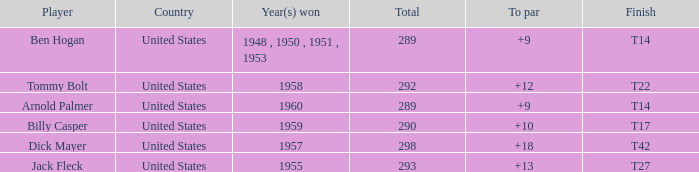What is Country, when Total is less than 290, and when Year(s) Won is 1960? United States. 